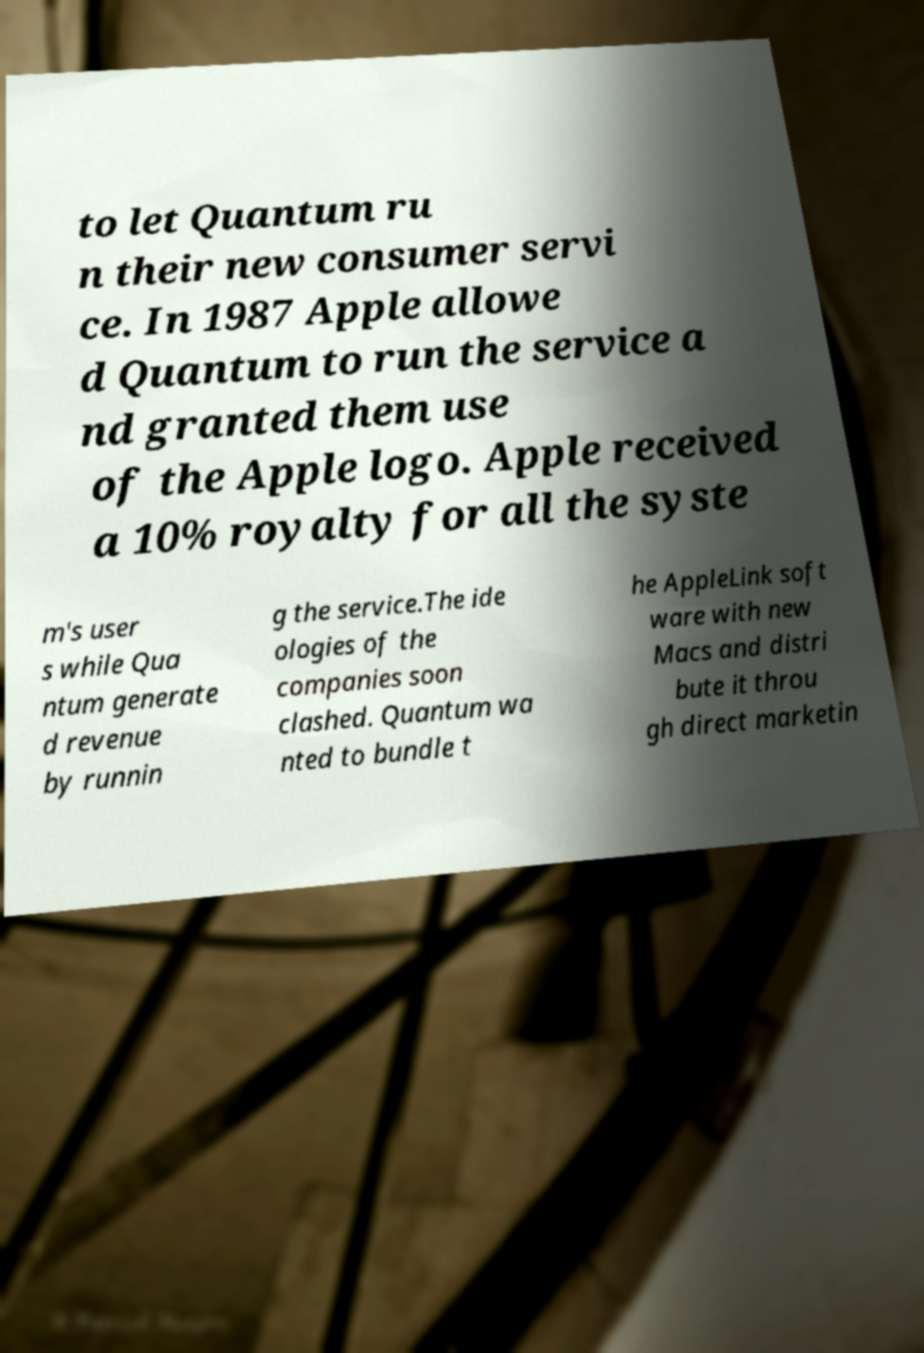For documentation purposes, I need the text within this image transcribed. Could you provide that? to let Quantum ru n their new consumer servi ce. In 1987 Apple allowe d Quantum to run the service a nd granted them use of the Apple logo. Apple received a 10% royalty for all the syste m's user s while Qua ntum generate d revenue by runnin g the service.The ide ologies of the companies soon clashed. Quantum wa nted to bundle t he AppleLink soft ware with new Macs and distri bute it throu gh direct marketin 